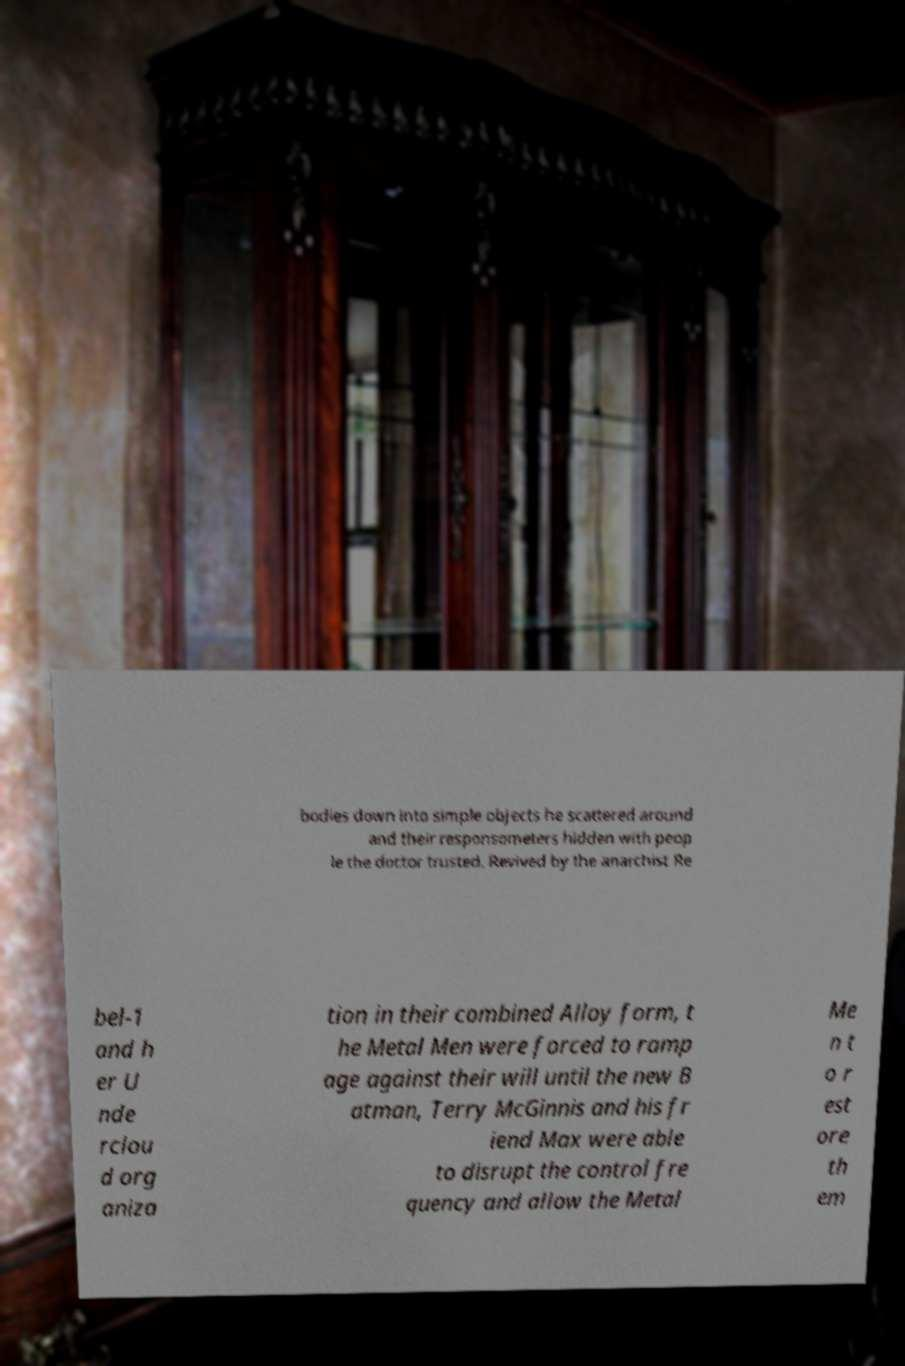Please identify and transcribe the text found in this image. bodies down into simple objects he scattered around and their responsometers hidden with peop le the doctor trusted. Revived by the anarchist Re bel-1 and h er U nde rclou d org aniza tion in their combined Alloy form, t he Metal Men were forced to ramp age against their will until the new B atman, Terry McGinnis and his fr iend Max were able to disrupt the control fre quency and allow the Metal Me n t o r est ore th em 